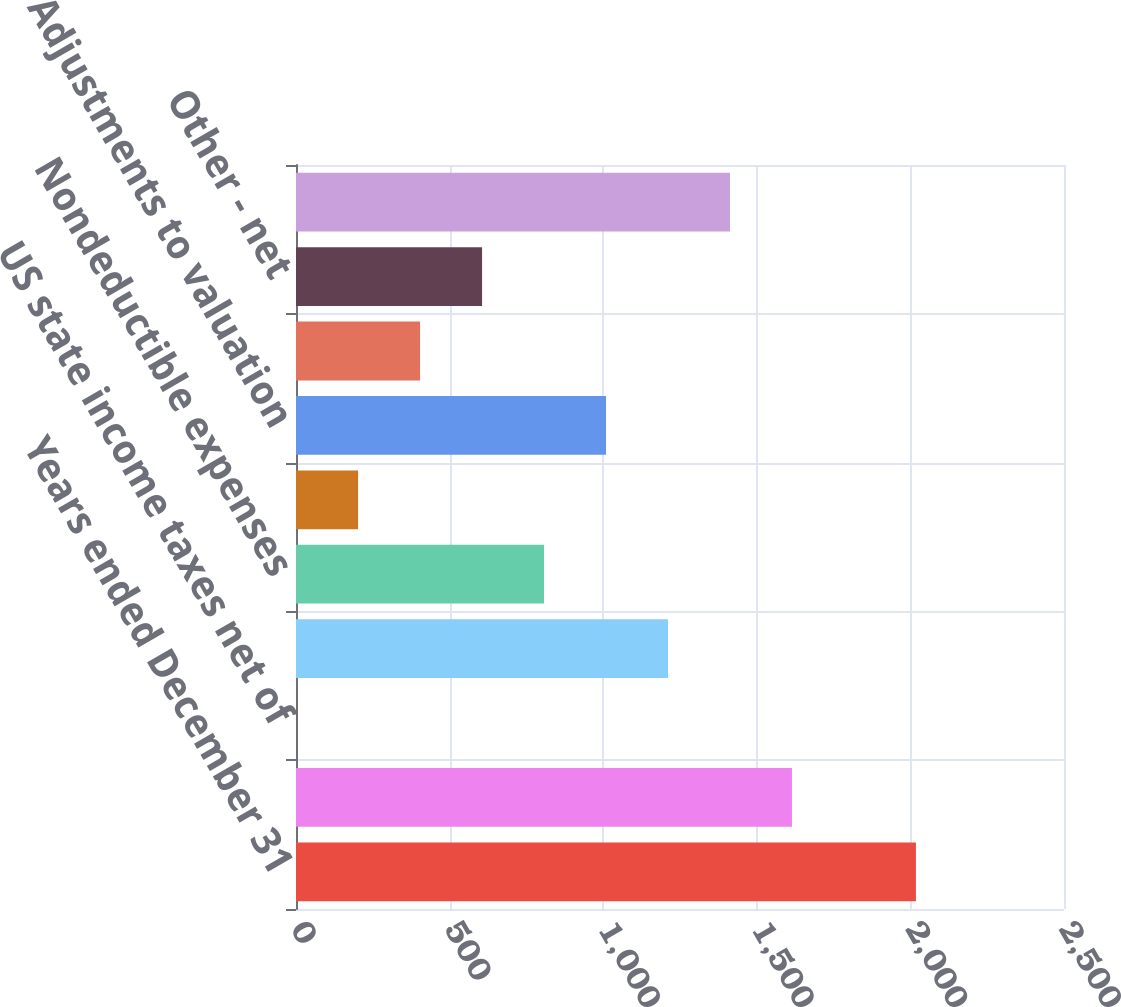Convert chart to OTSL. <chart><loc_0><loc_0><loc_500><loc_500><bar_chart><fcel>Years ended December 31<fcel>Statutory tax rate<fcel>US state income taxes net of<fcel>Taxes on international<fcel>Nondeductible expenses<fcel>Adjustments to prior year tax<fcel>Adjustments to valuation<fcel>Change in uncertain tax<fcel>Other - net<fcel>Effective tax rate<nl><fcel>2018<fcel>1614.48<fcel>0.4<fcel>1210.96<fcel>807.44<fcel>202.16<fcel>1009.2<fcel>403.92<fcel>605.68<fcel>1412.72<nl></chart> 